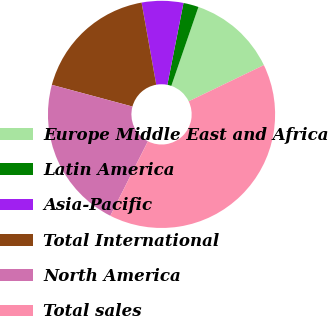Convert chart. <chart><loc_0><loc_0><loc_500><loc_500><pie_chart><fcel>Europe Middle East and Africa<fcel>Latin America<fcel>Asia-Pacific<fcel>Total International<fcel>North America<fcel>Total sales<nl><fcel>12.59%<fcel>2.17%<fcel>5.91%<fcel>18.0%<fcel>21.74%<fcel>39.59%<nl></chart> 